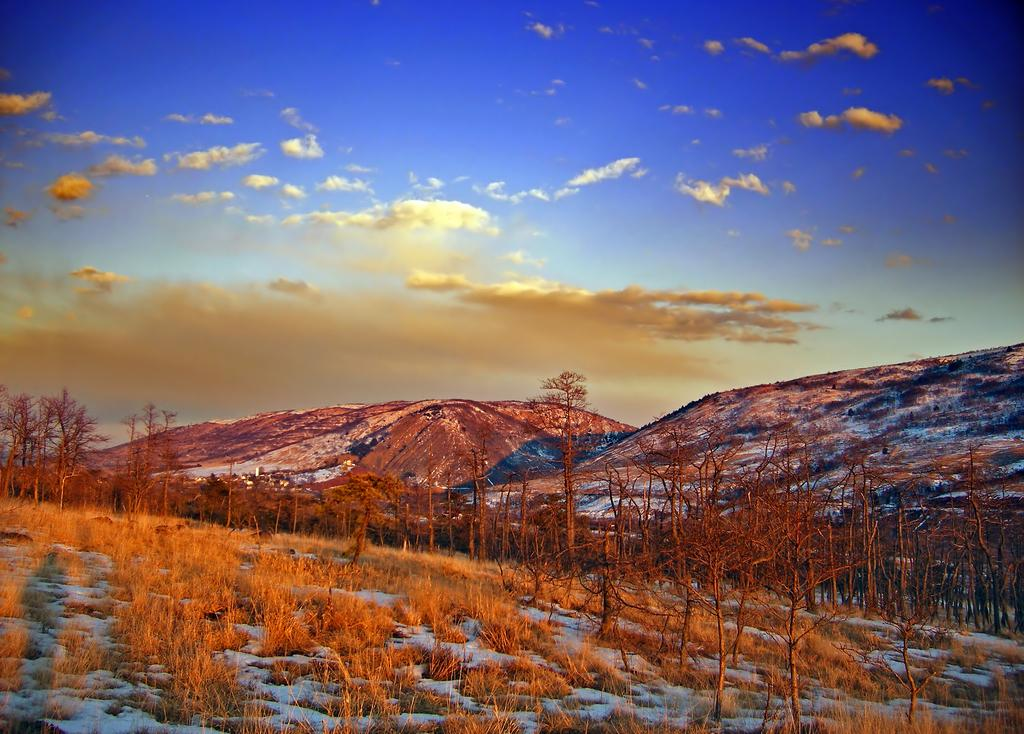What is the condition of the hill surface in the image? The hill surface has snow and dried grass. What type of vegetation can be seen on the hill? Trees are present on the hill. What can be seen in the background of the image? There are hills visible in the background, along with the sky. What is the weather like in the image? The presence of clouds in the sky suggests that it might be partly cloudy. Where is the hole that people can throw their waste into located on the hill? There is no hole or waste present in the image; it features a snowy hill with trees and a sky with clouds. 